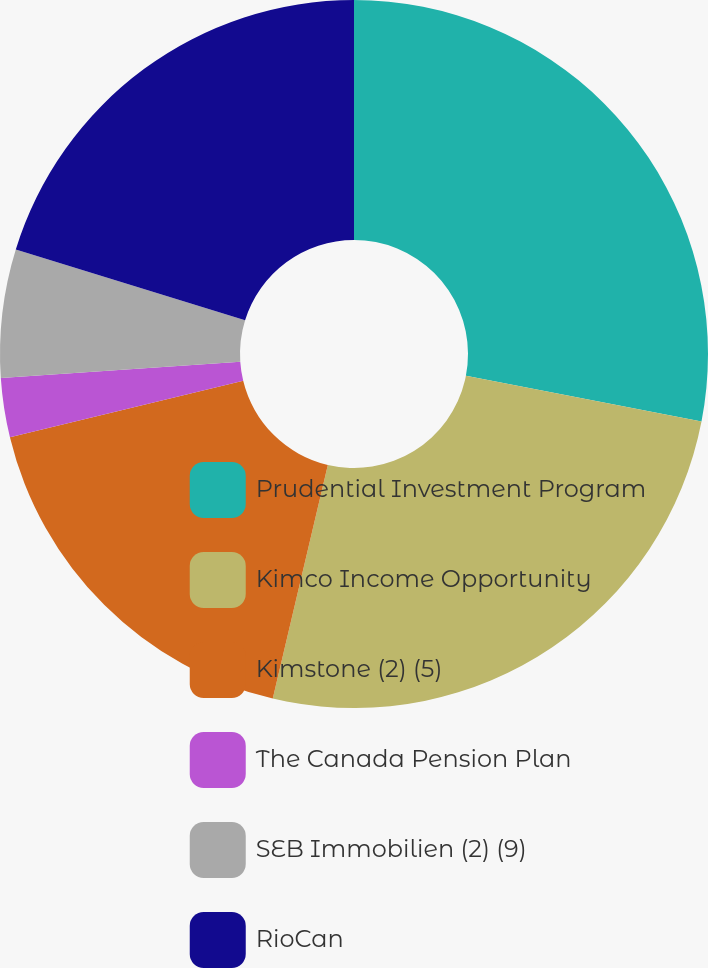<chart> <loc_0><loc_0><loc_500><loc_500><pie_chart><fcel>Prudential Investment Program<fcel>Kimco Income Opportunity<fcel>Kimstone (2) (5)<fcel>The Canada Pension Plan<fcel>SEB Immobilien (2) (9)<fcel>RioCan<nl><fcel>28.06%<fcel>25.63%<fcel>17.54%<fcel>2.7%<fcel>5.85%<fcel>20.23%<nl></chart> 